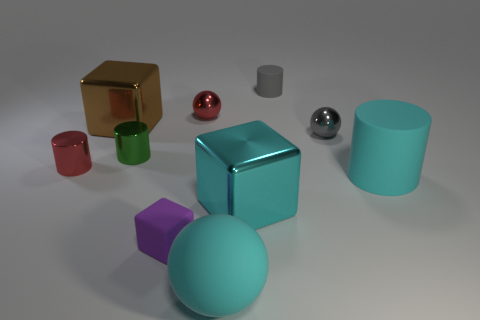Considering the arrangement of the objects, can you deduce any pattern or theme? The arrangement of the objects does not indicate a clear pattern or theme but seems like a deliberate scattered placement, possibly to demonstrate different shapes, materials, and colors in a comparison of their properties.  Is there a color that is dominant or more frequent in this composition? Cyan seems to be the dominant color in this composition, as it is featured prominently in both the large ball in the foreground and the cylinder to the right, creating a visual link across the scene. 